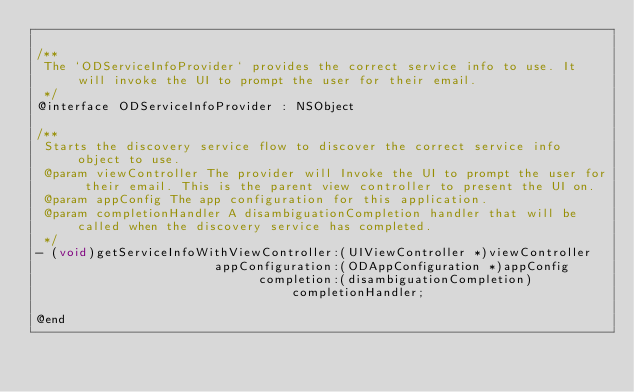<code> <loc_0><loc_0><loc_500><loc_500><_C_>
/**
 The `ODServiceInfoProvider` provides the correct service info to use. It will invoke the UI to prompt the user for their email.
 */
@interface ODServiceInfoProvider : NSObject

/**
 Starts the discovery service flow to discover the correct service info object to use.
 @param viewController The provider will Invoke the UI to prompt the user for their email. This is the parent view controller to present the UI on.
 @param appConfig The app configuration for this application.
 @param completionHandler A disambiguationCompletion handler that will be called when the discovery service has completed.
 */
- (void)getServiceInfoWithViewController:(UIViewController *)viewController
                        appConfiguration:(ODAppConfiguration *)appConfig
                              completion:(disambiguationCompletion)completionHandler;

@end
</code> 